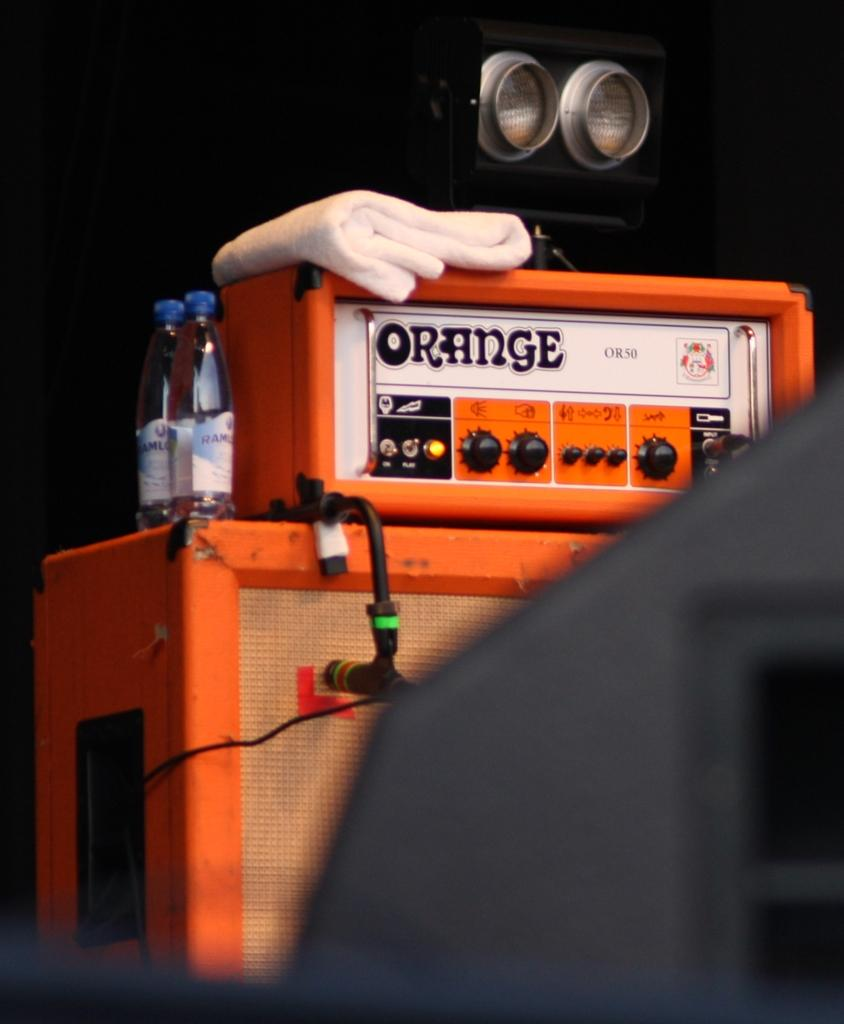<image>
Create a compact narrative representing the image presented. A partially blocked stack with an orange amp on top with 2 bottles of water on the side. 